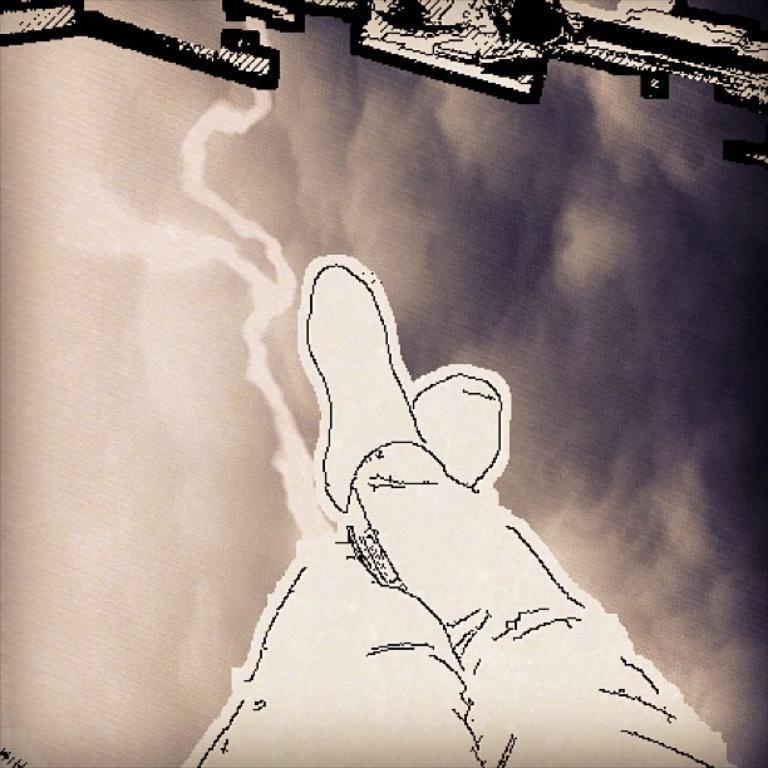Please provide a concise description of this image. This is an image with collage. In this image we can see the legs of a person. 